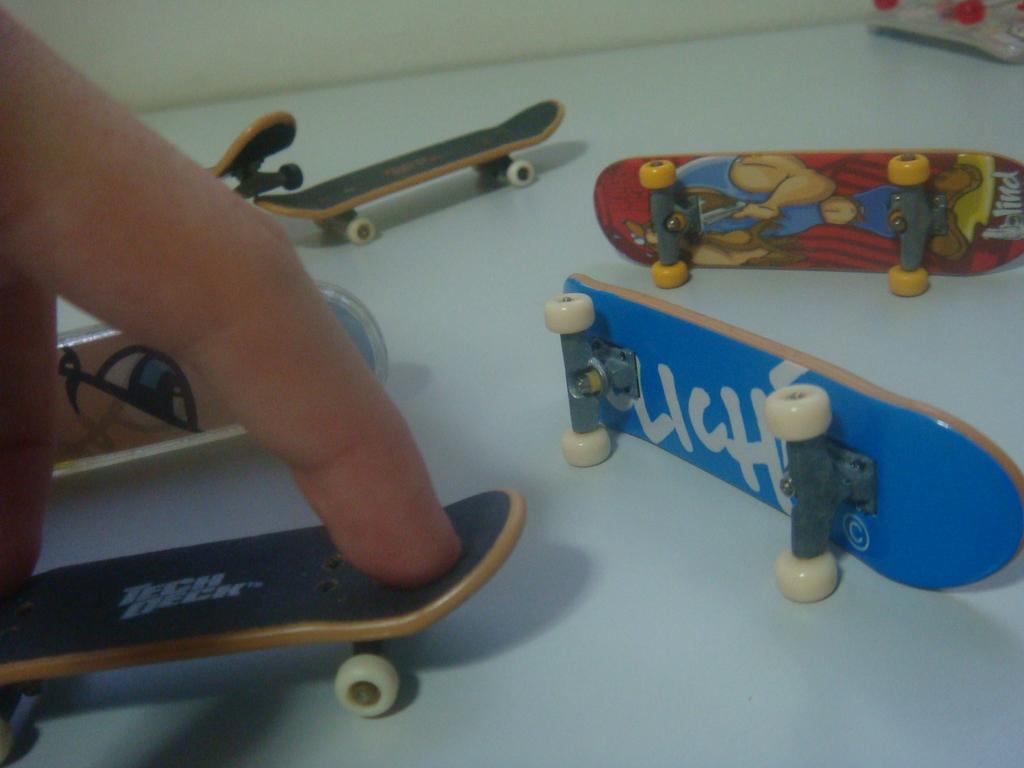In one or two sentences, can you explain what this image depicts? In this image we can see few skateboards on the table and person´s fingers on the skate board and wall in the background. 